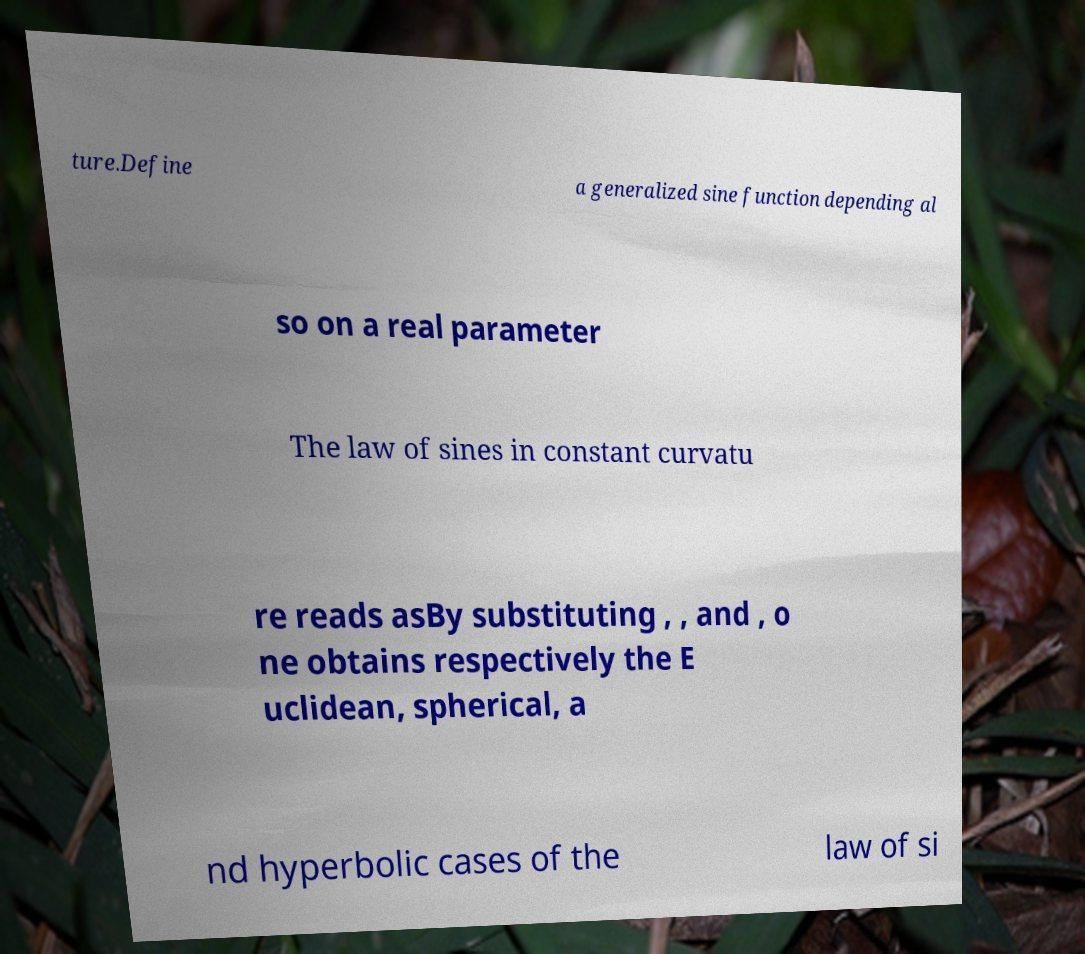Could you extract and type out the text from this image? ture.Define a generalized sine function depending al so on a real parameter The law of sines in constant curvatu re reads asBy substituting , , and , o ne obtains respectively the E uclidean, spherical, a nd hyperbolic cases of the law of si 